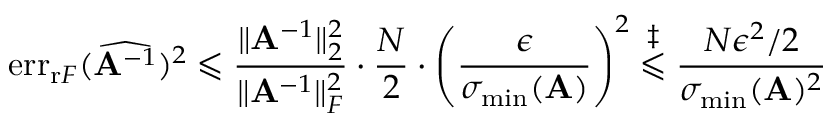<formula> <loc_0><loc_0><loc_500><loc_500>e r r _ { r F } ( \widehat { A ^ { - 1 } } ) ^ { 2 } \leqslant \frac { \| A ^ { - 1 } \| _ { 2 } ^ { 2 } } { \| A ^ { - 1 } \| _ { F } ^ { 2 } } \cdot \frac { N } { 2 } \cdot \left ( \frac { \epsilon } { \sigma _ { \min } ( A ) } \right ) ^ { 2 } \overset { \ddagger } { \leqslant } \frac { N \epsilon ^ { 2 } / 2 } { \sigma _ { \min } ( A ) ^ { 2 } }</formula> 